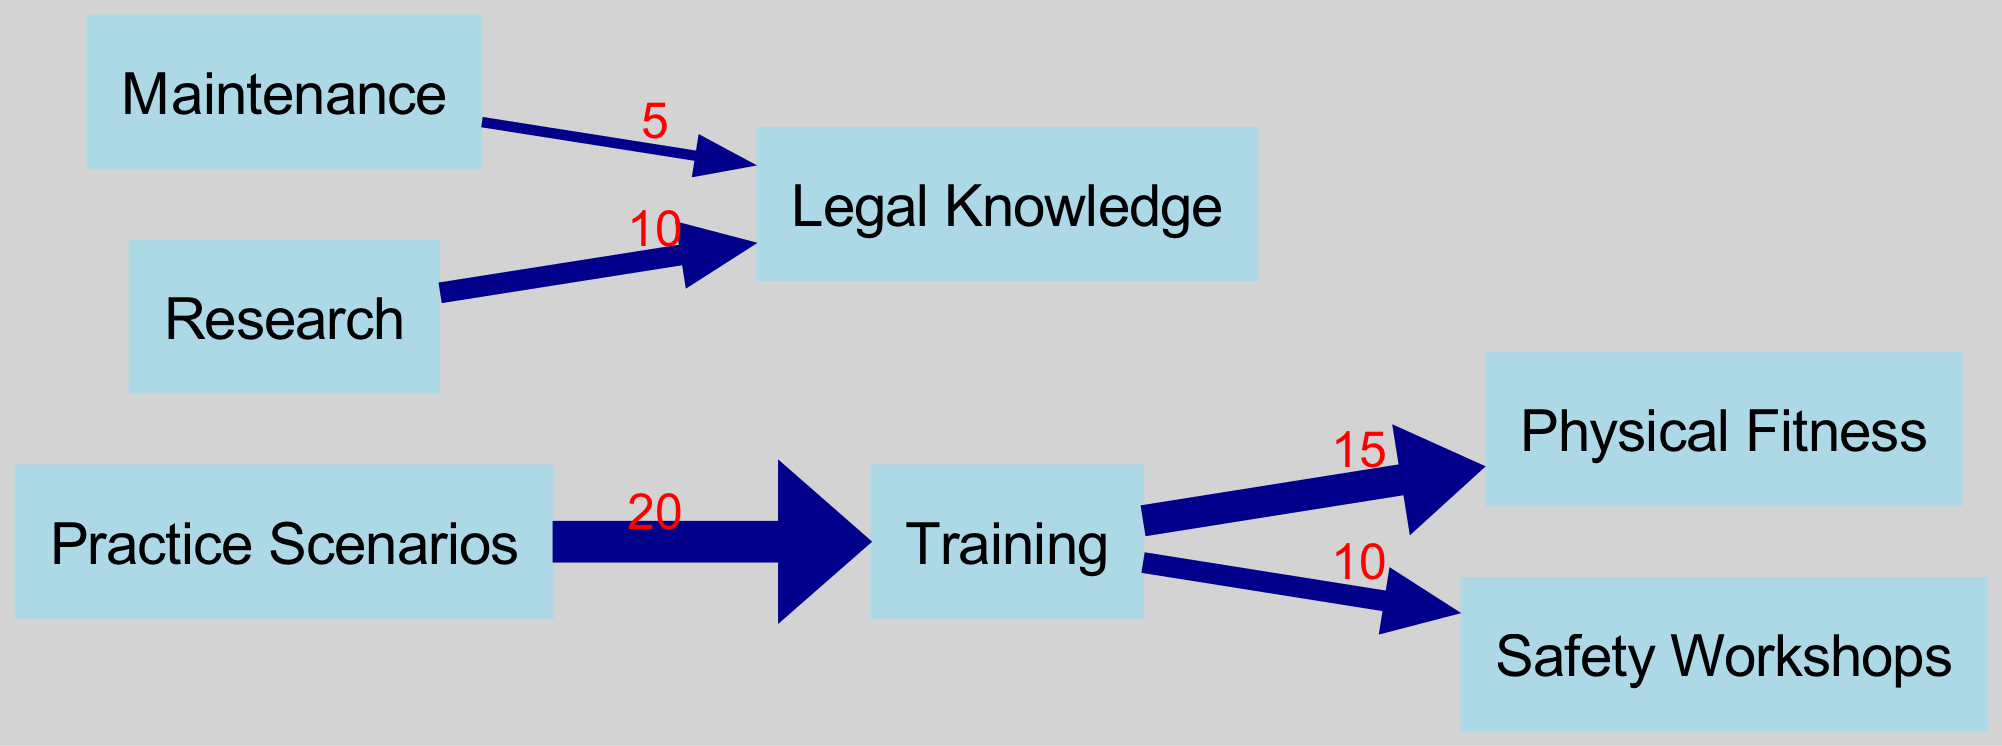What are the total hours dedicated to training? To find the total hours dedicated to training, we look at the links connected to the "Training" node. There are two connections: one to "Physical Fitness" with a value of 15 hours and another to "Safety Workshops" with a value of 10 hours. Adding these values together gives 15 + 10 = 25 hours.
Answer: 25 hours Which node receives the highest flow from practice scenarios? The "Practice Scenarios" node has an outgoing edge towards the "Training" node, with a flow value of 20. Since it is the only connection, it means that "Training" receives the highest flow from "Practice Scenarios".
Answer: Training What is the total value for legal knowledge derived from maintenance and research? "Legal Knowledge" has two incoming edges: one from "Maintenance" with a value of 5 and another from "Research" with a value of 10. To find the total value, we add 5 and 10 together, yielding 5 + 10 = 15.
Answer: 15 How many nodes are listed in the diagram? The diagram lists a total of 7 distinct nodes, including "Training", "Maintenance", "Research", "Practice Scenarios", "Physical Fitness", "Safety Workshops", and "Legal Knowledge". Counting these gives us a total of 7 nodes.
Answer: 7 What is the relationship between training and physical fitness in terms of flow value? The "Training" node flows into "Physical Fitness" with a value of 15. This indicates that 15 hours are allocated specifically for training connected to improving physical fitness.
Answer: 15 Which two nodes are connected through the maintenance node? The "Maintenance" node connects to "Legal Knowledge" with a flow value of 5. Therefore, the two nodes connected through "Maintenance" are "Maintenance" and "Legal Knowledge".
Answer: Legal Knowledge Which practice area has more dedicated hours, training or research? The node "Training" accounts for a total of 25 hours (15 + 10) while "Research" contributes 10 hours towards "Legal Knowledge". Comparing the two, 25 is greater than 10. Thus, "Training" has more dedicated hours compared to "Research".
Answer: Training 